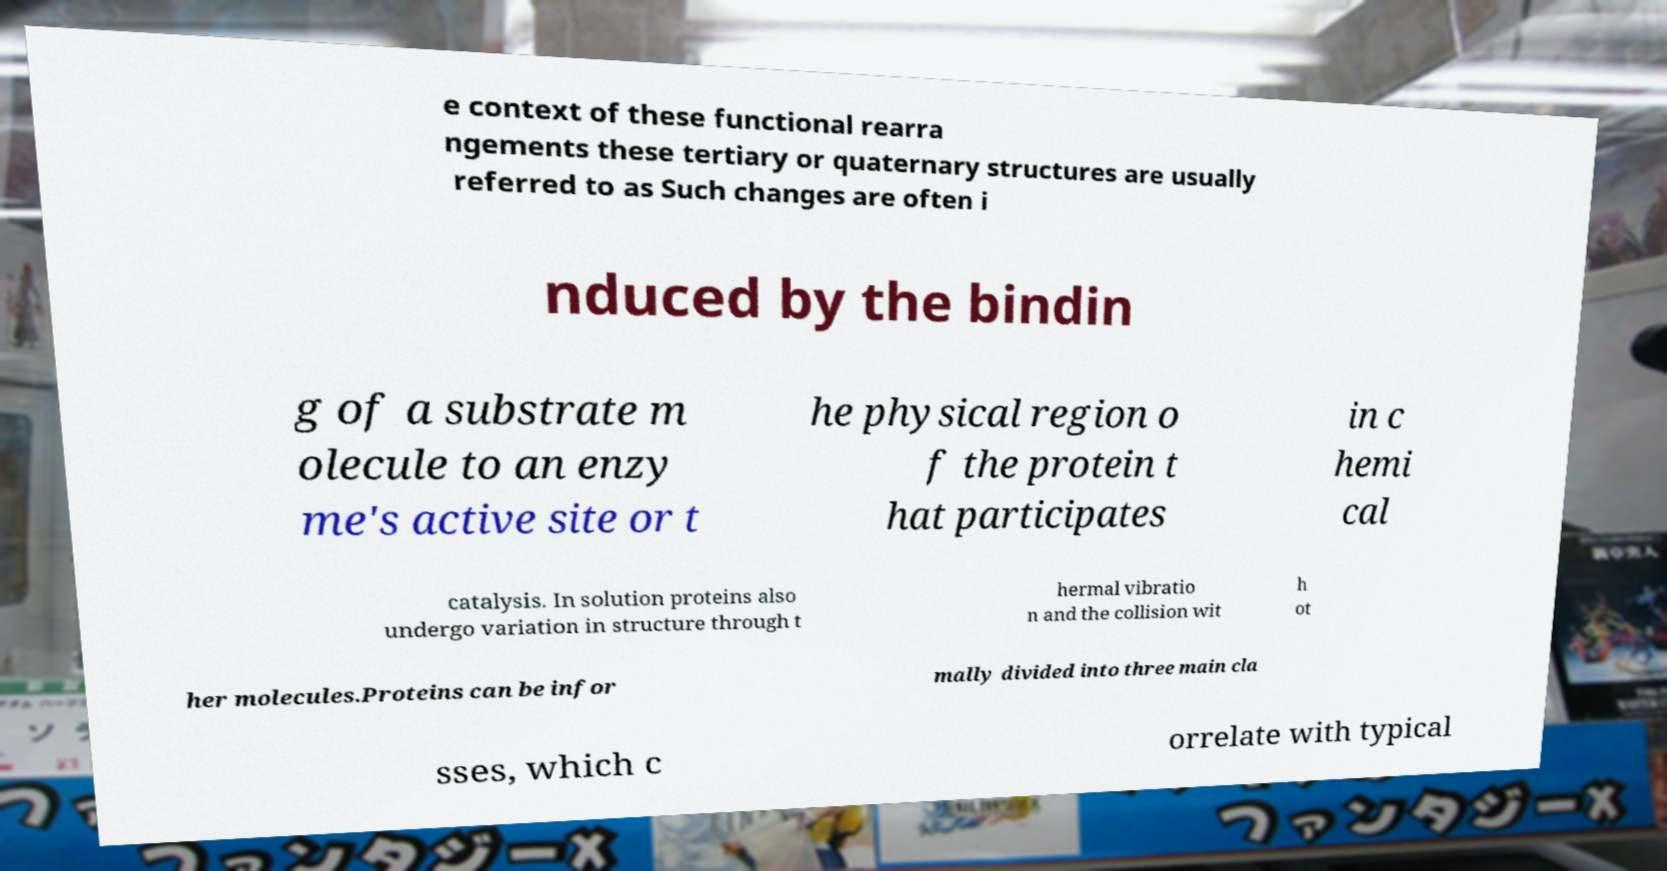Could you assist in decoding the text presented in this image and type it out clearly? e context of these functional rearra ngements these tertiary or quaternary structures are usually referred to as Such changes are often i nduced by the bindin g of a substrate m olecule to an enzy me's active site or t he physical region o f the protein t hat participates in c hemi cal catalysis. In solution proteins also undergo variation in structure through t hermal vibratio n and the collision wit h ot her molecules.Proteins can be infor mally divided into three main cla sses, which c orrelate with typical 